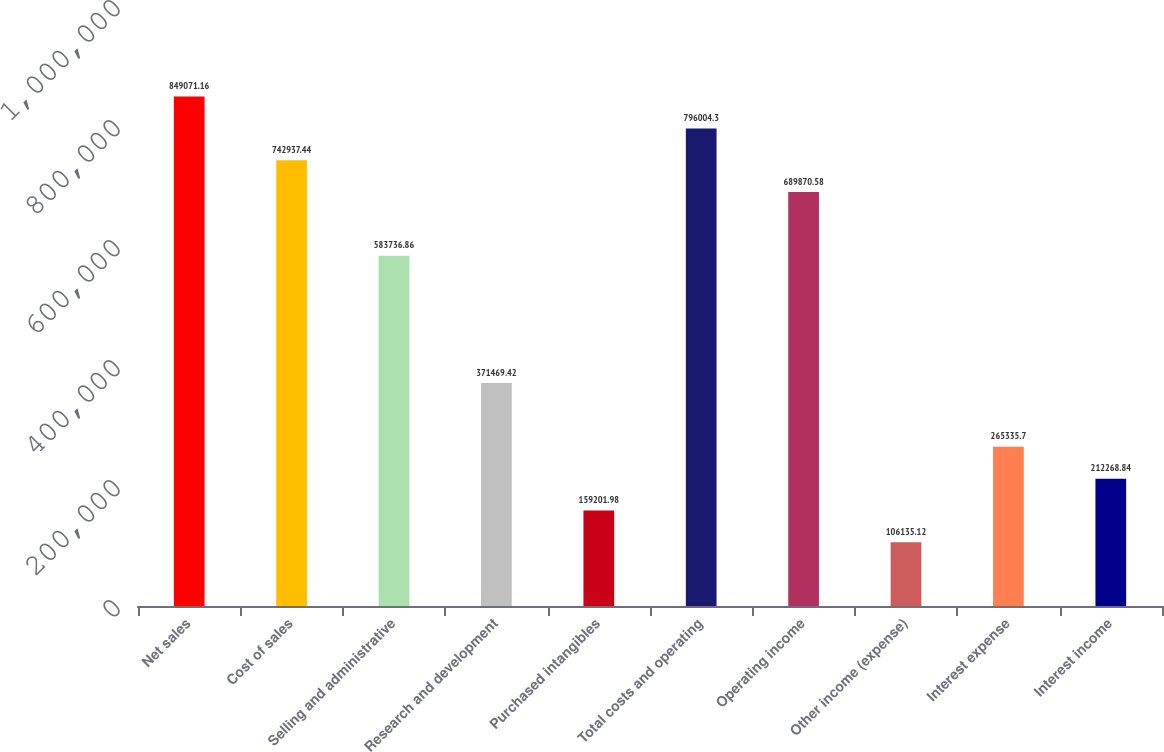<chart> <loc_0><loc_0><loc_500><loc_500><bar_chart><fcel>Net sales<fcel>Cost of sales<fcel>Selling and administrative<fcel>Research and development<fcel>Purchased intangibles<fcel>Total costs and operating<fcel>Operating income<fcel>Other income (expense)<fcel>Interest expense<fcel>Interest income<nl><fcel>849071<fcel>742937<fcel>583737<fcel>371469<fcel>159202<fcel>796004<fcel>689871<fcel>106135<fcel>265336<fcel>212269<nl></chart> 